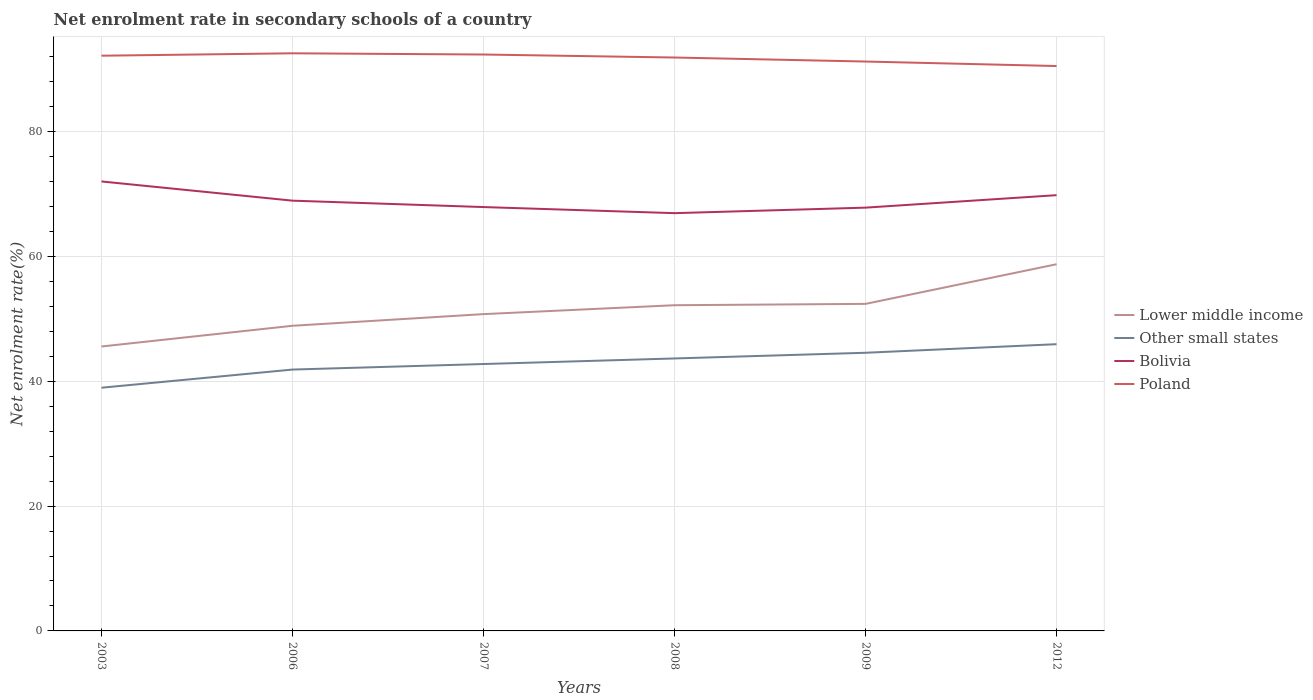Is the number of lines equal to the number of legend labels?
Offer a terse response. Yes. Across all years, what is the maximum net enrolment rate in secondary schools in Poland?
Give a very brief answer. 90.49. What is the total net enrolment rate in secondary schools in Bolivia in the graph?
Your answer should be compact. -1.91. What is the difference between the highest and the second highest net enrolment rate in secondary schools in Other small states?
Offer a terse response. 6.97. What is the difference between the highest and the lowest net enrolment rate in secondary schools in Bolivia?
Ensure brevity in your answer.  3. How many lines are there?
Provide a short and direct response. 4. What is the difference between two consecutive major ticks on the Y-axis?
Your answer should be very brief. 20. Are the values on the major ticks of Y-axis written in scientific E-notation?
Offer a very short reply. No. Does the graph contain grids?
Keep it short and to the point. Yes. Where does the legend appear in the graph?
Provide a succinct answer. Center right. What is the title of the graph?
Your response must be concise. Net enrolment rate in secondary schools of a country. Does "Turkmenistan" appear as one of the legend labels in the graph?
Your answer should be very brief. No. What is the label or title of the Y-axis?
Keep it short and to the point. Net enrolment rate(%). What is the Net enrolment rate(%) of Lower middle income in 2003?
Your response must be concise. 45.56. What is the Net enrolment rate(%) of Other small states in 2003?
Offer a very short reply. 38.96. What is the Net enrolment rate(%) in Bolivia in 2003?
Make the answer very short. 72. What is the Net enrolment rate(%) in Poland in 2003?
Make the answer very short. 92.14. What is the Net enrolment rate(%) of Lower middle income in 2006?
Make the answer very short. 48.88. What is the Net enrolment rate(%) in Other small states in 2006?
Provide a short and direct response. 41.87. What is the Net enrolment rate(%) of Bolivia in 2006?
Provide a short and direct response. 68.92. What is the Net enrolment rate(%) of Poland in 2006?
Provide a succinct answer. 92.52. What is the Net enrolment rate(%) of Lower middle income in 2007?
Give a very brief answer. 50.75. What is the Net enrolment rate(%) in Other small states in 2007?
Provide a short and direct response. 42.75. What is the Net enrolment rate(%) of Bolivia in 2007?
Your response must be concise. 67.89. What is the Net enrolment rate(%) of Poland in 2007?
Offer a terse response. 92.33. What is the Net enrolment rate(%) in Lower middle income in 2008?
Your answer should be compact. 52.17. What is the Net enrolment rate(%) in Other small states in 2008?
Your answer should be very brief. 43.64. What is the Net enrolment rate(%) of Bolivia in 2008?
Offer a terse response. 66.92. What is the Net enrolment rate(%) in Poland in 2008?
Your answer should be very brief. 91.85. What is the Net enrolment rate(%) in Lower middle income in 2009?
Keep it short and to the point. 52.39. What is the Net enrolment rate(%) of Other small states in 2009?
Your response must be concise. 44.55. What is the Net enrolment rate(%) in Bolivia in 2009?
Offer a terse response. 67.8. What is the Net enrolment rate(%) in Poland in 2009?
Your answer should be compact. 91.21. What is the Net enrolment rate(%) in Lower middle income in 2012?
Your answer should be very brief. 58.74. What is the Net enrolment rate(%) in Other small states in 2012?
Your response must be concise. 45.93. What is the Net enrolment rate(%) in Bolivia in 2012?
Make the answer very short. 69.8. What is the Net enrolment rate(%) of Poland in 2012?
Give a very brief answer. 90.49. Across all years, what is the maximum Net enrolment rate(%) of Lower middle income?
Keep it short and to the point. 58.74. Across all years, what is the maximum Net enrolment rate(%) in Other small states?
Provide a short and direct response. 45.93. Across all years, what is the maximum Net enrolment rate(%) in Bolivia?
Your answer should be compact. 72. Across all years, what is the maximum Net enrolment rate(%) in Poland?
Your answer should be very brief. 92.52. Across all years, what is the minimum Net enrolment rate(%) of Lower middle income?
Offer a terse response. 45.56. Across all years, what is the minimum Net enrolment rate(%) in Other small states?
Your response must be concise. 38.96. Across all years, what is the minimum Net enrolment rate(%) of Bolivia?
Provide a succinct answer. 66.92. Across all years, what is the minimum Net enrolment rate(%) of Poland?
Make the answer very short. 90.49. What is the total Net enrolment rate(%) in Lower middle income in the graph?
Provide a succinct answer. 308.48. What is the total Net enrolment rate(%) of Other small states in the graph?
Provide a succinct answer. 257.7. What is the total Net enrolment rate(%) in Bolivia in the graph?
Provide a succinct answer. 413.33. What is the total Net enrolment rate(%) of Poland in the graph?
Your response must be concise. 550.53. What is the difference between the Net enrolment rate(%) of Lower middle income in 2003 and that in 2006?
Provide a succinct answer. -3.32. What is the difference between the Net enrolment rate(%) of Other small states in 2003 and that in 2006?
Your response must be concise. -2.91. What is the difference between the Net enrolment rate(%) of Bolivia in 2003 and that in 2006?
Give a very brief answer. 3.08. What is the difference between the Net enrolment rate(%) in Poland in 2003 and that in 2006?
Give a very brief answer. -0.39. What is the difference between the Net enrolment rate(%) of Lower middle income in 2003 and that in 2007?
Your answer should be very brief. -5.19. What is the difference between the Net enrolment rate(%) in Other small states in 2003 and that in 2007?
Your answer should be compact. -3.8. What is the difference between the Net enrolment rate(%) in Bolivia in 2003 and that in 2007?
Provide a short and direct response. 4.1. What is the difference between the Net enrolment rate(%) in Poland in 2003 and that in 2007?
Your response must be concise. -0.19. What is the difference between the Net enrolment rate(%) of Lower middle income in 2003 and that in 2008?
Offer a terse response. -6.61. What is the difference between the Net enrolment rate(%) of Other small states in 2003 and that in 2008?
Provide a succinct answer. -4.69. What is the difference between the Net enrolment rate(%) of Bolivia in 2003 and that in 2008?
Provide a short and direct response. 5.08. What is the difference between the Net enrolment rate(%) in Poland in 2003 and that in 2008?
Offer a terse response. 0.29. What is the difference between the Net enrolment rate(%) in Lower middle income in 2003 and that in 2009?
Keep it short and to the point. -6.83. What is the difference between the Net enrolment rate(%) of Other small states in 2003 and that in 2009?
Offer a terse response. -5.6. What is the difference between the Net enrolment rate(%) of Bolivia in 2003 and that in 2009?
Make the answer very short. 4.19. What is the difference between the Net enrolment rate(%) of Poland in 2003 and that in 2009?
Ensure brevity in your answer.  0.93. What is the difference between the Net enrolment rate(%) of Lower middle income in 2003 and that in 2012?
Offer a very short reply. -13.18. What is the difference between the Net enrolment rate(%) in Other small states in 2003 and that in 2012?
Offer a terse response. -6.97. What is the difference between the Net enrolment rate(%) of Bolivia in 2003 and that in 2012?
Ensure brevity in your answer.  2.2. What is the difference between the Net enrolment rate(%) of Poland in 2003 and that in 2012?
Your response must be concise. 1.65. What is the difference between the Net enrolment rate(%) in Lower middle income in 2006 and that in 2007?
Your answer should be compact. -1.87. What is the difference between the Net enrolment rate(%) in Other small states in 2006 and that in 2007?
Provide a short and direct response. -0.89. What is the difference between the Net enrolment rate(%) of Bolivia in 2006 and that in 2007?
Make the answer very short. 1.03. What is the difference between the Net enrolment rate(%) of Poland in 2006 and that in 2007?
Your response must be concise. 0.19. What is the difference between the Net enrolment rate(%) in Lower middle income in 2006 and that in 2008?
Provide a succinct answer. -3.29. What is the difference between the Net enrolment rate(%) in Other small states in 2006 and that in 2008?
Make the answer very short. -1.78. What is the difference between the Net enrolment rate(%) of Bolivia in 2006 and that in 2008?
Provide a short and direct response. 2. What is the difference between the Net enrolment rate(%) of Poland in 2006 and that in 2008?
Provide a succinct answer. 0.67. What is the difference between the Net enrolment rate(%) of Lower middle income in 2006 and that in 2009?
Keep it short and to the point. -3.51. What is the difference between the Net enrolment rate(%) in Other small states in 2006 and that in 2009?
Ensure brevity in your answer.  -2.69. What is the difference between the Net enrolment rate(%) of Bolivia in 2006 and that in 2009?
Your answer should be compact. 1.12. What is the difference between the Net enrolment rate(%) in Poland in 2006 and that in 2009?
Ensure brevity in your answer.  1.32. What is the difference between the Net enrolment rate(%) of Lower middle income in 2006 and that in 2012?
Keep it short and to the point. -9.86. What is the difference between the Net enrolment rate(%) of Other small states in 2006 and that in 2012?
Your response must be concise. -4.06. What is the difference between the Net enrolment rate(%) of Bolivia in 2006 and that in 2012?
Offer a terse response. -0.88. What is the difference between the Net enrolment rate(%) of Poland in 2006 and that in 2012?
Give a very brief answer. 2.04. What is the difference between the Net enrolment rate(%) in Lower middle income in 2007 and that in 2008?
Ensure brevity in your answer.  -1.43. What is the difference between the Net enrolment rate(%) of Other small states in 2007 and that in 2008?
Your answer should be very brief. -0.89. What is the difference between the Net enrolment rate(%) of Bolivia in 2007 and that in 2008?
Make the answer very short. 0.98. What is the difference between the Net enrolment rate(%) in Poland in 2007 and that in 2008?
Give a very brief answer. 0.48. What is the difference between the Net enrolment rate(%) in Lower middle income in 2007 and that in 2009?
Provide a succinct answer. -1.64. What is the difference between the Net enrolment rate(%) of Other small states in 2007 and that in 2009?
Make the answer very short. -1.8. What is the difference between the Net enrolment rate(%) in Bolivia in 2007 and that in 2009?
Your answer should be very brief. 0.09. What is the difference between the Net enrolment rate(%) in Poland in 2007 and that in 2009?
Your response must be concise. 1.13. What is the difference between the Net enrolment rate(%) of Lower middle income in 2007 and that in 2012?
Your answer should be compact. -7.99. What is the difference between the Net enrolment rate(%) in Other small states in 2007 and that in 2012?
Keep it short and to the point. -3.18. What is the difference between the Net enrolment rate(%) of Bolivia in 2007 and that in 2012?
Your answer should be very brief. -1.91. What is the difference between the Net enrolment rate(%) of Poland in 2007 and that in 2012?
Give a very brief answer. 1.85. What is the difference between the Net enrolment rate(%) of Lower middle income in 2008 and that in 2009?
Your answer should be compact. -0.22. What is the difference between the Net enrolment rate(%) of Other small states in 2008 and that in 2009?
Your response must be concise. -0.91. What is the difference between the Net enrolment rate(%) in Bolivia in 2008 and that in 2009?
Provide a succinct answer. -0.88. What is the difference between the Net enrolment rate(%) in Poland in 2008 and that in 2009?
Make the answer very short. 0.64. What is the difference between the Net enrolment rate(%) in Lower middle income in 2008 and that in 2012?
Offer a very short reply. -6.57. What is the difference between the Net enrolment rate(%) of Other small states in 2008 and that in 2012?
Ensure brevity in your answer.  -2.28. What is the difference between the Net enrolment rate(%) in Bolivia in 2008 and that in 2012?
Ensure brevity in your answer.  -2.88. What is the difference between the Net enrolment rate(%) of Poland in 2008 and that in 2012?
Your response must be concise. 1.36. What is the difference between the Net enrolment rate(%) of Lower middle income in 2009 and that in 2012?
Keep it short and to the point. -6.35. What is the difference between the Net enrolment rate(%) in Other small states in 2009 and that in 2012?
Make the answer very short. -1.38. What is the difference between the Net enrolment rate(%) of Bolivia in 2009 and that in 2012?
Ensure brevity in your answer.  -2. What is the difference between the Net enrolment rate(%) of Poland in 2009 and that in 2012?
Give a very brief answer. 0.72. What is the difference between the Net enrolment rate(%) of Lower middle income in 2003 and the Net enrolment rate(%) of Other small states in 2006?
Your response must be concise. 3.69. What is the difference between the Net enrolment rate(%) in Lower middle income in 2003 and the Net enrolment rate(%) in Bolivia in 2006?
Make the answer very short. -23.36. What is the difference between the Net enrolment rate(%) of Lower middle income in 2003 and the Net enrolment rate(%) of Poland in 2006?
Provide a succinct answer. -46.96. What is the difference between the Net enrolment rate(%) of Other small states in 2003 and the Net enrolment rate(%) of Bolivia in 2006?
Your response must be concise. -29.96. What is the difference between the Net enrolment rate(%) of Other small states in 2003 and the Net enrolment rate(%) of Poland in 2006?
Make the answer very short. -53.57. What is the difference between the Net enrolment rate(%) of Bolivia in 2003 and the Net enrolment rate(%) of Poland in 2006?
Your answer should be compact. -20.53. What is the difference between the Net enrolment rate(%) in Lower middle income in 2003 and the Net enrolment rate(%) in Other small states in 2007?
Ensure brevity in your answer.  2.81. What is the difference between the Net enrolment rate(%) in Lower middle income in 2003 and the Net enrolment rate(%) in Bolivia in 2007?
Ensure brevity in your answer.  -22.33. What is the difference between the Net enrolment rate(%) of Lower middle income in 2003 and the Net enrolment rate(%) of Poland in 2007?
Your response must be concise. -46.77. What is the difference between the Net enrolment rate(%) of Other small states in 2003 and the Net enrolment rate(%) of Bolivia in 2007?
Provide a succinct answer. -28.94. What is the difference between the Net enrolment rate(%) in Other small states in 2003 and the Net enrolment rate(%) in Poland in 2007?
Your answer should be compact. -53.37. What is the difference between the Net enrolment rate(%) in Bolivia in 2003 and the Net enrolment rate(%) in Poland in 2007?
Your response must be concise. -20.33. What is the difference between the Net enrolment rate(%) of Lower middle income in 2003 and the Net enrolment rate(%) of Other small states in 2008?
Your response must be concise. 1.92. What is the difference between the Net enrolment rate(%) of Lower middle income in 2003 and the Net enrolment rate(%) of Bolivia in 2008?
Offer a terse response. -21.36. What is the difference between the Net enrolment rate(%) of Lower middle income in 2003 and the Net enrolment rate(%) of Poland in 2008?
Provide a short and direct response. -46.29. What is the difference between the Net enrolment rate(%) of Other small states in 2003 and the Net enrolment rate(%) of Bolivia in 2008?
Your response must be concise. -27.96. What is the difference between the Net enrolment rate(%) of Other small states in 2003 and the Net enrolment rate(%) of Poland in 2008?
Offer a very short reply. -52.89. What is the difference between the Net enrolment rate(%) in Bolivia in 2003 and the Net enrolment rate(%) in Poland in 2008?
Offer a very short reply. -19.85. What is the difference between the Net enrolment rate(%) in Lower middle income in 2003 and the Net enrolment rate(%) in Other small states in 2009?
Ensure brevity in your answer.  1.01. What is the difference between the Net enrolment rate(%) of Lower middle income in 2003 and the Net enrolment rate(%) of Bolivia in 2009?
Your answer should be compact. -22.24. What is the difference between the Net enrolment rate(%) in Lower middle income in 2003 and the Net enrolment rate(%) in Poland in 2009?
Keep it short and to the point. -45.65. What is the difference between the Net enrolment rate(%) of Other small states in 2003 and the Net enrolment rate(%) of Bolivia in 2009?
Keep it short and to the point. -28.85. What is the difference between the Net enrolment rate(%) of Other small states in 2003 and the Net enrolment rate(%) of Poland in 2009?
Your response must be concise. -52.25. What is the difference between the Net enrolment rate(%) in Bolivia in 2003 and the Net enrolment rate(%) in Poland in 2009?
Your response must be concise. -19.21. What is the difference between the Net enrolment rate(%) in Lower middle income in 2003 and the Net enrolment rate(%) in Other small states in 2012?
Offer a terse response. -0.37. What is the difference between the Net enrolment rate(%) of Lower middle income in 2003 and the Net enrolment rate(%) of Bolivia in 2012?
Your response must be concise. -24.24. What is the difference between the Net enrolment rate(%) in Lower middle income in 2003 and the Net enrolment rate(%) in Poland in 2012?
Your answer should be compact. -44.92. What is the difference between the Net enrolment rate(%) of Other small states in 2003 and the Net enrolment rate(%) of Bolivia in 2012?
Provide a succinct answer. -30.84. What is the difference between the Net enrolment rate(%) of Other small states in 2003 and the Net enrolment rate(%) of Poland in 2012?
Offer a very short reply. -51.53. What is the difference between the Net enrolment rate(%) in Bolivia in 2003 and the Net enrolment rate(%) in Poland in 2012?
Provide a short and direct response. -18.49. What is the difference between the Net enrolment rate(%) in Lower middle income in 2006 and the Net enrolment rate(%) in Other small states in 2007?
Offer a terse response. 6.13. What is the difference between the Net enrolment rate(%) of Lower middle income in 2006 and the Net enrolment rate(%) of Bolivia in 2007?
Your response must be concise. -19.02. What is the difference between the Net enrolment rate(%) of Lower middle income in 2006 and the Net enrolment rate(%) of Poland in 2007?
Give a very brief answer. -43.45. What is the difference between the Net enrolment rate(%) in Other small states in 2006 and the Net enrolment rate(%) in Bolivia in 2007?
Provide a succinct answer. -26.03. What is the difference between the Net enrolment rate(%) of Other small states in 2006 and the Net enrolment rate(%) of Poland in 2007?
Offer a terse response. -50.47. What is the difference between the Net enrolment rate(%) in Bolivia in 2006 and the Net enrolment rate(%) in Poland in 2007?
Give a very brief answer. -23.41. What is the difference between the Net enrolment rate(%) in Lower middle income in 2006 and the Net enrolment rate(%) in Other small states in 2008?
Give a very brief answer. 5.23. What is the difference between the Net enrolment rate(%) in Lower middle income in 2006 and the Net enrolment rate(%) in Bolivia in 2008?
Provide a short and direct response. -18.04. What is the difference between the Net enrolment rate(%) of Lower middle income in 2006 and the Net enrolment rate(%) of Poland in 2008?
Provide a short and direct response. -42.97. What is the difference between the Net enrolment rate(%) of Other small states in 2006 and the Net enrolment rate(%) of Bolivia in 2008?
Keep it short and to the point. -25.05. What is the difference between the Net enrolment rate(%) in Other small states in 2006 and the Net enrolment rate(%) in Poland in 2008?
Offer a terse response. -49.98. What is the difference between the Net enrolment rate(%) in Bolivia in 2006 and the Net enrolment rate(%) in Poland in 2008?
Ensure brevity in your answer.  -22.93. What is the difference between the Net enrolment rate(%) in Lower middle income in 2006 and the Net enrolment rate(%) in Other small states in 2009?
Offer a very short reply. 4.32. What is the difference between the Net enrolment rate(%) of Lower middle income in 2006 and the Net enrolment rate(%) of Bolivia in 2009?
Offer a very short reply. -18.92. What is the difference between the Net enrolment rate(%) in Lower middle income in 2006 and the Net enrolment rate(%) in Poland in 2009?
Offer a terse response. -42.33. What is the difference between the Net enrolment rate(%) of Other small states in 2006 and the Net enrolment rate(%) of Bolivia in 2009?
Provide a succinct answer. -25.94. What is the difference between the Net enrolment rate(%) of Other small states in 2006 and the Net enrolment rate(%) of Poland in 2009?
Your answer should be very brief. -49.34. What is the difference between the Net enrolment rate(%) in Bolivia in 2006 and the Net enrolment rate(%) in Poland in 2009?
Your answer should be very brief. -22.29. What is the difference between the Net enrolment rate(%) of Lower middle income in 2006 and the Net enrolment rate(%) of Other small states in 2012?
Make the answer very short. 2.95. What is the difference between the Net enrolment rate(%) in Lower middle income in 2006 and the Net enrolment rate(%) in Bolivia in 2012?
Offer a terse response. -20.92. What is the difference between the Net enrolment rate(%) in Lower middle income in 2006 and the Net enrolment rate(%) in Poland in 2012?
Your response must be concise. -41.61. What is the difference between the Net enrolment rate(%) of Other small states in 2006 and the Net enrolment rate(%) of Bolivia in 2012?
Offer a terse response. -27.93. What is the difference between the Net enrolment rate(%) of Other small states in 2006 and the Net enrolment rate(%) of Poland in 2012?
Provide a succinct answer. -48.62. What is the difference between the Net enrolment rate(%) in Bolivia in 2006 and the Net enrolment rate(%) in Poland in 2012?
Make the answer very short. -21.57. What is the difference between the Net enrolment rate(%) in Lower middle income in 2007 and the Net enrolment rate(%) in Other small states in 2008?
Offer a very short reply. 7.1. What is the difference between the Net enrolment rate(%) of Lower middle income in 2007 and the Net enrolment rate(%) of Bolivia in 2008?
Your answer should be very brief. -16.17. What is the difference between the Net enrolment rate(%) in Lower middle income in 2007 and the Net enrolment rate(%) in Poland in 2008?
Ensure brevity in your answer.  -41.1. What is the difference between the Net enrolment rate(%) in Other small states in 2007 and the Net enrolment rate(%) in Bolivia in 2008?
Offer a terse response. -24.17. What is the difference between the Net enrolment rate(%) of Other small states in 2007 and the Net enrolment rate(%) of Poland in 2008?
Your answer should be compact. -49.1. What is the difference between the Net enrolment rate(%) of Bolivia in 2007 and the Net enrolment rate(%) of Poland in 2008?
Provide a short and direct response. -23.96. What is the difference between the Net enrolment rate(%) in Lower middle income in 2007 and the Net enrolment rate(%) in Other small states in 2009?
Offer a very short reply. 6.19. What is the difference between the Net enrolment rate(%) of Lower middle income in 2007 and the Net enrolment rate(%) of Bolivia in 2009?
Provide a succinct answer. -17.06. What is the difference between the Net enrolment rate(%) of Lower middle income in 2007 and the Net enrolment rate(%) of Poland in 2009?
Ensure brevity in your answer.  -40.46. What is the difference between the Net enrolment rate(%) of Other small states in 2007 and the Net enrolment rate(%) of Bolivia in 2009?
Keep it short and to the point. -25.05. What is the difference between the Net enrolment rate(%) of Other small states in 2007 and the Net enrolment rate(%) of Poland in 2009?
Your response must be concise. -48.45. What is the difference between the Net enrolment rate(%) of Bolivia in 2007 and the Net enrolment rate(%) of Poland in 2009?
Make the answer very short. -23.31. What is the difference between the Net enrolment rate(%) of Lower middle income in 2007 and the Net enrolment rate(%) of Other small states in 2012?
Ensure brevity in your answer.  4.82. What is the difference between the Net enrolment rate(%) of Lower middle income in 2007 and the Net enrolment rate(%) of Bolivia in 2012?
Keep it short and to the point. -19.05. What is the difference between the Net enrolment rate(%) of Lower middle income in 2007 and the Net enrolment rate(%) of Poland in 2012?
Your response must be concise. -39.74. What is the difference between the Net enrolment rate(%) in Other small states in 2007 and the Net enrolment rate(%) in Bolivia in 2012?
Ensure brevity in your answer.  -27.05. What is the difference between the Net enrolment rate(%) of Other small states in 2007 and the Net enrolment rate(%) of Poland in 2012?
Keep it short and to the point. -47.73. What is the difference between the Net enrolment rate(%) of Bolivia in 2007 and the Net enrolment rate(%) of Poland in 2012?
Keep it short and to the point. -22.59. What is the difference between the Net enrolment rate(%) in Lower middle income in 2008 and the Net enrolment rate(%) in Other small states in 2009?
Your response must be concise. 7.62. What is the difference between the Net enrolment rate(%) in Lower middle income in 2008 and the Net enrolment rate(%) in Bolivia in 2009?
Offer a terse response. -15.63. What is the difference between the Net enrolment rate(%) of Lower middle income in 2008 and the Net enrolment rate(%) of Poland in 2009?
Provide a succinct answer. -39.03. What is the difference between the Net enrolment rate(%) of Other small states in 2008 and the Net enrolment rate(%) of Bolivia in 2009?
Your answer should be very brief. -24.16. What is the difference between the Net enrolment rate(%) in Other small states in 2008 and the Net enrolment rate(%) in Poland in 2009?
Offer a terse response. -47.56. What is the difference between the Net enrolment rate(%) of Bolivia in 2008 and the Net enrolment rate(%) of Poland in 2009?
Your answer should be very brief. -24.29. What is the difference between the Net enrolment rate(%) of Lower middle income in 2008 and the Net enrolment rate(%) of Other small states in 2012?
Make the answer very short. 6.24. What is the difference between the Net enrolment rate(%) of Lower middle income in 2008 and the Net enrolment rate(%) of Bolivia in 2012?
Offer a very short reply. -17.63. What is the difference between the Net enrolment rate(%) in Lower middle income in 2008 and the Net enrolment rate(%) in Poland in 2012?
Ensure brevity in your answer.  -38.31. What is the difference between the Net enrolment rate(%) in Other small states in 2008 and the Net enrolment rate(%) in Bolivia in 2012?
Give a very brief answer. -26.16. What is the difference between the Net enrolment rate(%) in Other small states in 2008 and the Net enrolment rate(%) in Poland in 2012?
Provide a succinct answer. -46.84. What is the difference between the Net enrolment rate(%) of Bolivia in 2008 and the Net enrolment rate(%) of Poland in 2012?
Offer a very short reply. -23.57. What is the difference between the Net enrolment rate(%) in Lower middle income in 2009 and the Net enrolment rate(%) in Other small states in 2012?
Ensure brevity in your answer.  6.46. What is the difference between the Net enrolment rate(%) in Lower middle income in 2009 and the Net enrolment rate(%) in Bolivia in 2012?
Your answer should be very brief. -17.41. What is the difference between the Net enrolment rate(%) in Lower middle income in 2009 and the Net enrolment rate(%) in Poland in 2012?
Your answer should be very brief. -38.1. What is the difference between the Net enrolment rate(%) of Other small states in 2009 and the Net enrolment rate(%) of Bolivia in 2012?
Make the answer very short. -25.25. What is the difference between the Net enrolment rate(%) of Other small states in 2009 and the Net enrolment rate(%) of Poland in 2012?
Give a very brief answer. -45.93. What is the difference between the Net enrolment rate(%) in Bolivia in 2009 and the Net enrolment rate(%) in Poland in 2012?
Keep it short and to the point. -22.68. What is the average Net enrolment rate(%) in Lower middle income per year?
Provide a succinct answer. 51.41. What is the average Net enrolment rate(%) of Other small states per year?
Your answer should be very brief. 42.95. What is the average Net enrolment rate(%) in Bolivia per year?
Make the answer very short. 68.89. What is the average Net enrolment rate(%) of Poland per year?
Give a very brief answer. 91.76. In the year 2003, what is the difference between the Net enrolment rate(%) of Lower middle income and Net enrolment rate(%) of Other small states?
Provide a succinct answer. 6.6. In the year 2003, what is the difference between the Net enrolment rate(%) in Lower middle income and Net enrolment rate(%) in Bolivia?
Make the answer very short. -26.44. In the year 2003, what is the difference between the Net enrolment rate(%) in Lower middle income and Net enrolment rate(%) in Poland?
Ensure brevity in your answer.  -46.58. In the year 2003, what is the difference between the Net enrolment rate(%) in Other small states and Net enrolment rate(%) in Bolivia?
Offer a terse response. -33.04. In the year 2003, what is the difference between the Net enrolment rate(%) in Other small states and Net enrolment rate(%) in Poland?
Your answer should be compact. -53.18. In the year 2003, what is the difference between the Net enrolment rate(%) of Bolivia and Net enrolment rate(%) of Poland?
Provide a succinct answer. -20.14. In the year 2006, what is the difference between the Net enrolment rate(%) of Lower middle income and Net enrolment rate(%) of Other small states?
Give a very brief answer. 7.01. In the year 2006, what is the difference between the Net enrolment rate(%) of Lower middle income and Net enrolment rate(%) of Bolivia?
Offer a terse response. -20.04. In the year 2006, what is the difference between the Net enrolment rate(%) in Lower middle income and Net enrolment rate(%) in Poland?
Ensure brevity in your answer.  -43.65. In the year 2006, what is the difference between the Net enrolment rate(%) of Other small states and Net enrolment rate(%) of Bolivia?
Provide a short and direct response. -27.05. In the year 2006, what is the difference between the Net enrolment rate(%) of Other small states and Net enrolment rate(%) of Poland?
Give a very brief answer. -50.66. In the year 2006, what is the difference between the Net enrolment rate(%) of Bolivia and Net enrolment rate(%) of Poland?
Offer a terse response. -23.6. In the year 2007, what is the difference between the Net enrolment rate(%) in Lower middle income and Net enrolment rate(%) in Other small states?
Your answer should be compact. 7.99. In the year 2007, what is the difference between the Net enrolment rate(%) of Lower middle income and Net enrolment rate(%) of Bolivia?
Offer a terse response. -17.15. In the year 2007, what is the difference between the Net enrolment rate(%) of Lower middle income and Net enrolment rate(%) of Poland?
Ensure brevity in your answer.  -41.58. In the year 2007, what is the difference between the Net enrolment rate(%) of Other small states and Net enrolment rate(%) of Bolivia?
Offer a very short reply. -25.14. In the year 2007, what is the difference between the Net enrolment rate(%) in Other small states and Net enrolment rate(%) in Poland?
Offer a terse response. -49.58. In the year 2007, what is the difference between the Net enrolment rate(%) of Bolivia and Net enrolment rate(%) of Poland?
Offer a very short reply. -24.44. In the year 2008, what is the difference between the Net enrolment rate(%) of Lower middle income and Net enrolment rate(%) of Other small states?
Your answer should be very brief. 8.53. In the year 2008, what is the difference between the Net enrolment rate(%) of Lower middle income and Net enrolment rate(%) of Bolivia?
Offer a terse response. -14.75. In the year 2008, what is the difference between the Net enrolment rate(%) in Lower middle income and Net enrolment rate(%) in Poland?
Ensure brevity in your answer.  -39.68. In the year 2008, what is the difference between the Net enrolment rate(%) of Other small states and Net enrolment rate(%) of Bolivia?
Give a very brief answer. -23.27. In the year 2008, what is the difference between the Net enrolment rate(%) of Other small states and Net enrolment rate(%) of Poland?
Offer a very short reply. -48.2. In the year 2008, what is the difference between the Net enrolment rate(%) in Bolivia and Net enrolment rate(%) in Poland?
Your answer should be very brief. -24.93. In the year 2009, what is the difference between the Net enrolment rate(%) in Lower middle income and Net enrolment rate(%) in Other small states?
Provide a short and direct response. 7.83. In the year 2009, what is the difference between the Net enrolment rate(%) of Lower middle income and Net enrolment rate(%) of Bolivia?
Your answer should be compact. -15.42. In the year 2009, what is the difference between the Net enrolment rate(%) of Lower middle income and Net enrolment rate(%) of Poland?
Provide a short and direct response. -38.82. In the year 2009, what is the difference between the Net enrolment rate(%) in Other small states and Net enrolment rate(%) in Bolivia?
Provide a short and direct response. -23.25. In the year 2009, what is the difference between the Net enrolment rate(%) in Other small states and Net enrolment rate(%) in Poland?
Provide a short and direct response. -46.65. In the year 2009, what is the difference between the Net enrolment rate(%) of Bolivia and Net enrolment rate(%) of Poland?
Ensure brevity in your answer.  -23.4. In the year 2012, what is the difference between the Net enrolment rate(%) of Lower middle income and Net enrolment rate(%) of Other small states?
Offer a terse response. 12.81. In the year 2012, what is the difference between the Net enrolment rate(%) in Lower middle income and Net enrolment rate(%) in Bolivia?
Your answer should be very brief. -11.06. In the year 2012, what is the difference between the Net enrolment rate(%) in Lower middle income and Net enrolment rate(%) in Poland?
Offer a very short reply. -31.75. In the year 2012, what is the difference between the Net enrolment rate(%) of Other small states and Net enrolment rate(%) of Bolivia?
Your answer should be very brief. -23.87. In the year 2012, what is the difference between the Net enrolment rate(%) of Other small states and Net enrolment rate(%) of Poland?
Your answer should be compact. -44.56. In the year 2012, what is the difference between the Net enrolment rate(%) of Bolivia and Net enrolment rate(%) of Poland?
Offer a terse response. -20.68. What is the ratio of the Net enrolment rate(%) of Lower middle income in 2003 to that in 2006?
Offer a terse response. 0.93. What is the ratio of the Net enrolment rate(%) of Other small states in 2003 to that in 2006?
Offer a very short reply. 0.93. What is the ratio of the Net enrolment rate(%) in Bolivia in 2003 to that in 2006?
Provide a short and direct response. 1.04. What is the ratio of the Net enrolment rate(%) of Poland in 2003 to that in 2006?
Your answer should be very brief. 1. What is the ratio of the Net enrolment rate(%) of Lower middle income in 2003 to that in 2007?
Give a very brief answer. 0.9. What is the ratio of the Net enrolment rate(%) in Other small states in 2003 to that in 2007?
Ensure brevity in your answer.  0.91. What is the ratio of the Net enrolment rate(%) in Bolivia in 2003 to that in 2007?
Your answer should be very brief. 1.06. What is the ratio of the Net enrolment rate(%) in Lower middle income in 2003 to that in 2008?
Offer a terse response. 0.87. What is the ratio of the Net enrolment rate(%) in Other small states in 2003 to that in 2008?
Give a very brief answer. 0.89. What is the ratio of the Net enrolment rate(%) of Bolivia in 2003 to that in 2008?
Keep it short and to the point. 1.08. What is the ratio of the Net enrolment rate(%) in Poland in 2003 to that in 2008?
Your response must be concise. 1. What is the ratio of the Net enrolment rate(%) in Lower middle income in 2003 to that in 2009?
Offer a terse response. 0.87. What is the ratio of the Net enrolment rate(%) of Other small states in 2003 to that in 2009?
Provide a succinct answer. 0.87. What is the ratio of the Net enrolment rate(%) in Bolivia in 2003 to that in 2009?
Your answer should be very brief. 1.06. What is the ratio of the Net enrolment rate(%) in Poland in 2003 to that in 2009?
Ensure brevity in your answer.  1.01. What is the ratio of the Net enrolment rate(%) in Lower middle income in 2003 to that in 2012?
Offer a terse response. 0.78. What is the ratio of the Net enrolment rate(%) of Other small states in 2003 to that in 2012?
Your answer should be very brief. 0.85. What is the ratio of the Net enrolment rate(%) in Bolivia in 2003 to that in 2012?
Provide a short and direct response. 1.03. What is the ratio of the Net enrolment rate(%) of Poland in 2003 to that in 2012?
Give a very brief answer. 1.02. What is the ratio of the Net enrolment rate(%) in Lower middle income in 2006 to that in 2007?
Provide a short and direct response. 0.96. What is the ratio of the Net enrolment rate(%) of Other small states in 2006 to that in 2007?
Keep it short and to the point. 0.98. What is the ratio of the Net enrolment rate(%) in Bolivia in 2006 to that in 2007?
Your answer should be very brief. 1.02. What is the ratio of the Net enrolment rate(%) in Poland in 2006 to that in 2007?
Provide a short and direct response. 1. What is the ratio of the Net enrolment rate(%) in Lower middle income in 2006 to that in 2008?
Your answer should be very brief. 0.94. What is the ratio of the Net enrolment rate(%) of Other small states in 2006 to that in 2008?
Your answer should be very brief. 0.96. What is the ratio of the Net enrolment rate(%) in Bolivia in 2006 to that in 2008?
Offer a very short reply. 1.03. What is the ratio of the Net enrolment rate(%) of Poland in 2006 to that in 2008?
Your answer should be compact. 1.01. What is the ratio of the Net enrolment rate(%) of Lower middle income in 2006 to that in 2009?
Give a very brief answer. 0.93. What is the ratio of the Net enrolment rate(%) in Other small states in 2006 to that in 2009?
Your response must be concise. 0.94. What is the ratio of the Net enrolment rate(%) of Bolivia in 2006 to that in 2009?
Your answer should be compact. 1.02. What is the ratio of the Net enrolment rate(%) in Poland in 2006 to that in 2009?
Your response must be concise. 1.01. What is the ratio of the Net enrolment rate(%) of Lower middle income in 2006 to that in 2012?
Offer a terse response. 0.83. What is the ratio of the Net enrolment rate(%) in Other small states in 2006 to that in 2012?
Your answer should be very brief. 0.91. What is the ratio of the Net enrolment rate(%) in Bolivia in 2006 to that in 2012?
Provide a short and direct response. 0.99. What is the ratio of the Net enrolment rate(%) in Poland in 2006 to that in 2012?
Your answer should be compact. 1.02. What is the ratio of the Net enrolment rate(%) of Lower middle income in 2007 to that in 2008?
Ensure brevity in your answer.  0.97. What is the ratio of the Net enrolment rate(%) in Other small states in 2007 to that in 2008?
Keep it short and to the point. 0.98. What is the ratio of the Net enrolment rate(%) of Bolivia in 2007 to that in 2008?
Your answer should be very brief. 1.01. What is the ratio of the Net enrolment rate(%) of Poland in 2007 to that in 2008?
Provide a succinct answer. 1.01. What is the ratio of the Net enrolment rate(%) of Lower middle income in 2007 to that in 2009?
Offer a very short reply. 0.97. What is the ratio of the Net enrolment rate(%) of Other small states in 2007 to that in 2009?
Your response must be concise. 0.96. What is the ratio of the Net enrolment rate(%) in Bolivia in 2007 to that in 2009?
Provide a short and direct response. 1. What is the ratio of the Net enrolment rate(%) in Poland in 2007 to that in 2009?
Your answer should be very brief. 1.01. What is the ratio of the Net enrolment rate(%) of Lower middle income in 2007 to that in 2012?
Your answer should be compact. 0.86. What is the ratio of the Net enrolment rate(%) in Other small states in 2007 to that in 2012?
Provide a short and direct response. 0.93. What is the ratio of the Net enrolment rate(%) of Bolivia in 2007 to that in 2012?
Offer a very short reply. 0.97. What is the ratio of the Net enrolment rate(%) of Poland in 2007 to that in 2012?
Your answer should be compact. 1.02. What is the ratio of the Net enrolment rate(%) of Lower middle income in 2008 to that in 2009?
Offer a very short reply. 1. What is the ratio of the Net enrolment rate(%) in Other small states in 2008 to that in 2009?
Your answer should be compact. 0.98. What is the ratio of the Net enrolment rate(%) in Bolivia in 2008 to that in 2009?
Offer a terse response. 0.99. What is the ratio of the Net enrolment rate(%) in Poland in 2008 to that in 2009?
Offer a terse response. 1.01. What is the ratio of the Net enrolment rate(%) of Lower middle income in 2008 to that in 2012?
Provide a short and direct response. 0.89. What is the ratio of the Net enrolment rate(%) of Other small states in 2008 to that in 2012?
Your response must be concise. 0.95. What is the ratio of the Net enrolment rate(%) in Bolivia in 2008 to that in 2012?
Offer a terse response. 0.96. What is the ratio of the Net enrolment rate(%) in Poland in 2008 to that in 2012?
Your response must be concise. 1.02. What is the ratio of the Net enrolment rate(%) in Lower middle income in 2009 to that in 2012?
Provide a succinct answer. 0.89. What is the ratio of the Net enrolment rate(%) of Other small states in 2009 to that in 2012?
Your answer should be compact. 0.97. What is the ratio of the Net enrolment rate(%) in Bolivia in 2009 to that in 2012?
Provide a succinct answer. 0.97. What is the difference between the highest and the second highest Net enrolment rate(%) in Lower middle income?
Your answer should be compact. 6.35. What is the difference between the highest and the second highest Net enrolment rate(%) of Other small states?
Give a very brief answer. 1.38. What is the difference between the highest and the second highest Net enrolment rate(%) in Bolivia?
Your answer should be compact. 2.2. What is the difference between the highest and the second highest Net enrolment rate(%) in Poland?
Ensure brevity in your answer.  0.19. What is the difference between the highest and the lowest Net enrolment rate(%) in Lower middle income?
Give a very brief answer. 13.18. What is the difference between the highest and the lowest Net enrolment rate(%) in Other small states?
Your answer should be compact. 6.97. What is the difference between the highest and the lowest Net enrolment rate(%) in Bolivia?
Offer a terse response. 5.08. What is the difference between the highest and the lowest Net enrolment rate(%) of Poland?
Your answer should be very brief. 2.04. 